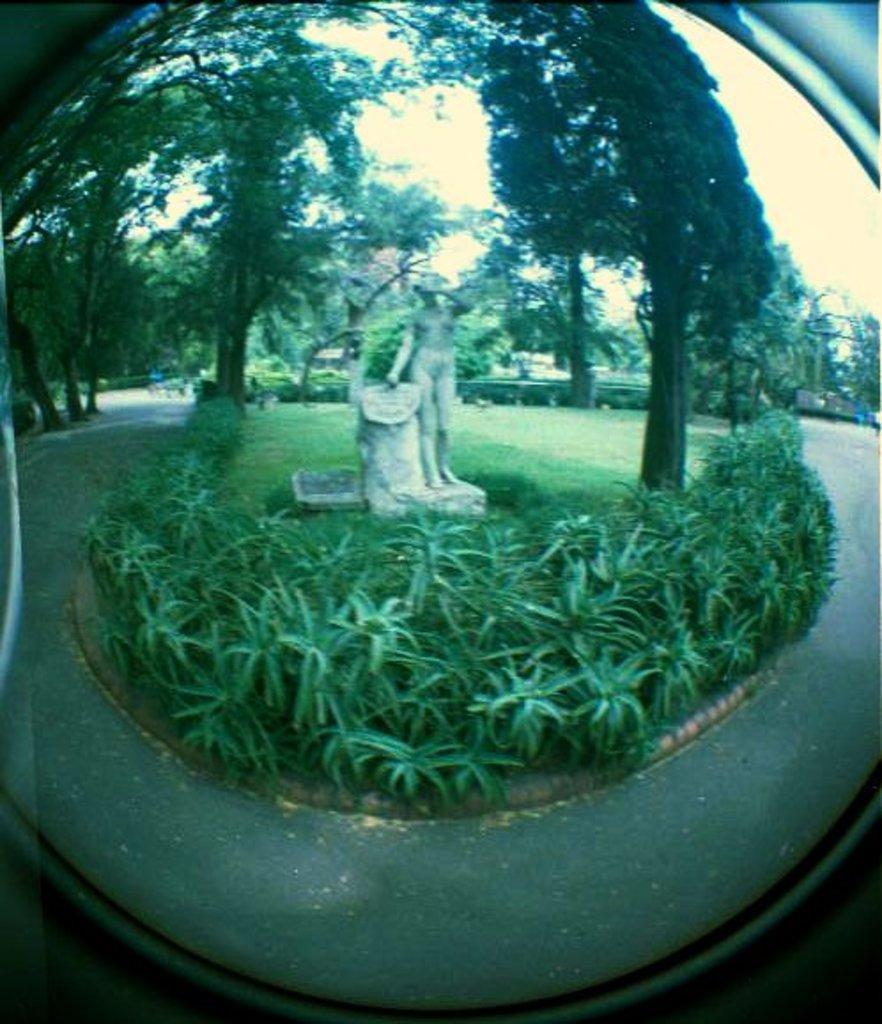How would you summarize this image in a sentence or two? This picture contains a mirror in which the statue of woman and plants are seen. We even see the road and trees in the garden. 